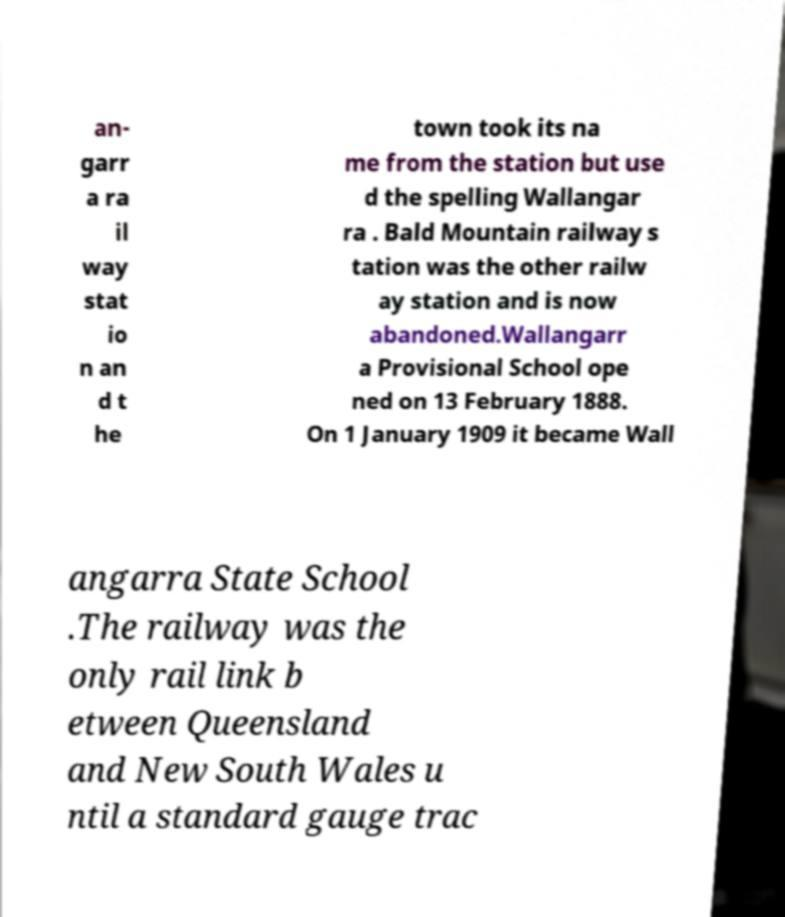Could you extract and type out the text from this image? an- garr a ra il way stat io n an d t he town took its na me from the station but use d the spelling Wallangar ra . Bald Mountain railway s tation was the other railw ay station and is now abandoned.Wallangarr a Provisional School ope ned on 13 February 1888. On 1 January 1909 it became Wall angarra State School .The railway was the only rail link b etween Queensland and New South Wales u ntil a standard gauge trac 